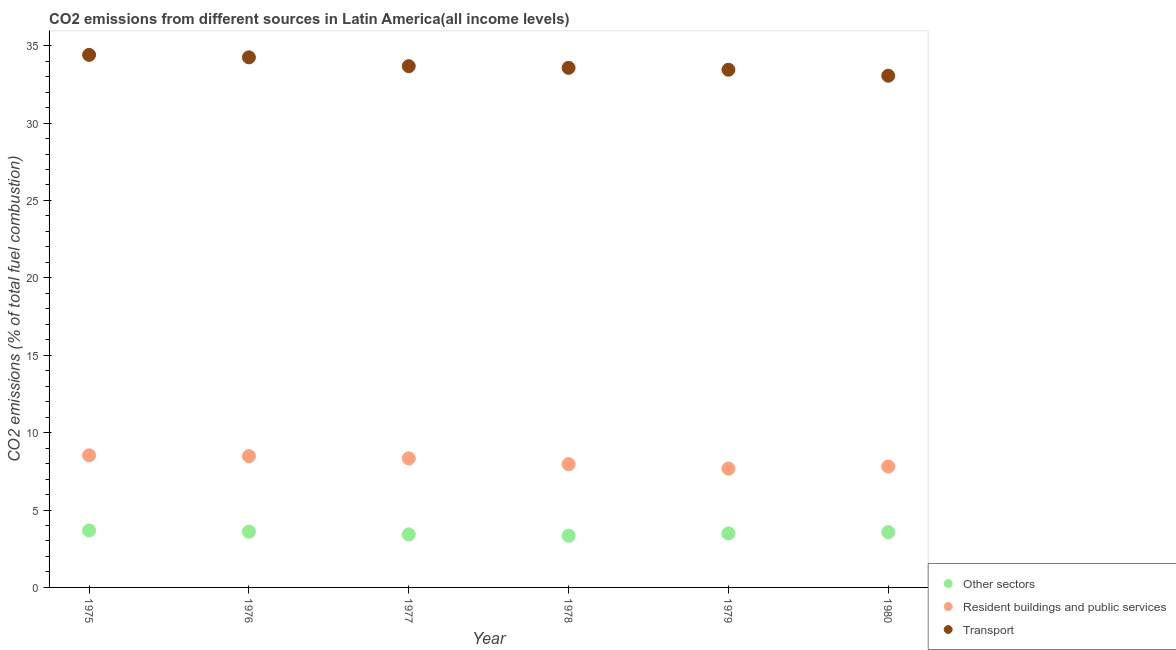Is the number of dotlines equal to the number of legend labels?
Your response must be concise. Yes. What is the percentage of co2 emissions from resident buildings and public services in 1979?
Ensure brevity in your answer.  7.68. Across all years, what is the maximum percentage of co2 emissions from other sectors?
Keep it short and to the point. 3.68. Across all years, what is the minimum percentage of co2 emissions from resident buildings and public services?
Ensure brevity in your answer.  7.68. In which year was the percentage of co2 emissions from transport maximum?
Your response must be concise. 1975. In which year was the percentage of co2 emissions from other sectors minimum?
Offer a very short reply. 1978. What is the total percentage of co2 emissions from resident buildings and public services in the graph?
Provide a succinct answer. 48.82. What is the difference between the percentage of co2 emissions from transport in 1977 and that in 1978?
Your answer should be compact. 0.11. What is the difference between the percentage of co2 emissions from resident buildings and public services in 1978 and the percentage of co2 emissions from transport in 1977?
Provide a succinct answer. -25.72. What is the average percentage of co2 emissions from resident buildings and public services per year?
Keep it short and to the point. 8.14. In the year 1980, what is the difference between the percentage of co2 emissions from resident buildings and public services and percentage of co2 emissions from other sectors?
Offer a terse response. 4.24. What is the ratio of the percentage of co2 emissions from other sectors in 1978 to that in 1979?
Ensure brevity in your answer.  0.96. Is the percentage of co2 emissions from resident buildings and public services in 1976 less than that in 1977?
Your response must be concise. No. What is the difference between the highest and the second highest percentage of co2 emissions from resident buildings and public services?
Give a very brief answer. 0.05. What is the difference between the highest and the lowest percentage of co2 emissions from transport?
Provide a succinct answer. 1.35. In how many years, is the percentage of co2 emissions from transport greater than the average percentage of co2 emissions from transport taken over all years?
Your answer should be very brief. 2. Is it the case that in every year, the sum of the percentage of co2 emissions from other sectors and percentage of co2 emissions from resident buildings and public services is greater than the percentage of co2 emissions from transport?
Provide a succinct answer. No. Is the percentage of co2 emissions from transport strictly greater than the percentage of co2 emissions from other sectors over the years?
Your answer should be compact. Yes. How many dotlines are there?
Your answer should be compact. 3. What is the difference between two consecutive major ticks on the Y-axis?
Your answer should be very brief. 5. Are the values on the major ticks of Y-axis written in scientific E-notation?
Provide a succinct answer. No. Does the graph contain grids?
Your answer should be very brief. No. Where does the legend appear in the graph?
Give a very brief answer. Bottom right. How many legend labels are there?
Make the answer very short. 3. What is the title of the graph?
Keep it short and to the point. CO2 emissions from different sources in Latin America(all income levels). What is the label or title of the Y-axis?
Ensure brevity in your answer.  CO2 emissions (% of total fuel combustion). What is the CO2 emissions (% of total fuel combustion) in Other sectors in 1975?
Make the answer very short. 3.68. What is the CO2 emissions (% of total fuel combustion) in Resident buildings and public services in 1975?
Keep it short and to the point. 8.54. What is the CO2 emissions (% of total fuel combustion) of Transport in 1975?
Ensure brevity in your answer.  34.41. What is the CO2 emissions (% of total fuel combustion) of Other sectors in 1976?
Your answer should be very brief. 3.6. What is the CO2 emissions (% of total fuel combustion) in Resident buildings and public services in 1976?
Provide a short and direct response. 8.48. What is the CO2 emissions (% of total fuel combustion) in Transport in 1976?
Make the answer very short. 34.25. What is the CO2 emissions (% of total fuel combustion) in Other sectors in 1977?
Provide a short and direct response. 3.43. What is the CO2 emissions (% of total fuel combustion) of Resident buildings and public services in 1977?
Offer a terse response. 8.34. What is the CO2 emissions (% of total fuel combustion) in Transport in 1977?
Offer a very short reply. 33.68. What is the CO2 emissions (% of total fuel combustion) of Other sectors in 1978?
Your response must be concise. 3.34. What is the CO2 emissions (% of total fuel combustion) of Resident buildings and public services in 1978?
Offer a very short reply. 7.96. What is the CO2 emissions (% of total fuel combustion) of Transport in 1978?
Offer a terse response. 33.57. What is the CO2 emissions (% of total fuel combustion) of Other sectors in 1979?
Your answer should be compact. 3.49. What is the CO2 emissions (% of total fuel combustion) of Resident buildings and public services in 1979?
Make the answer very short. 7.68. What is the CO2 emissions (% of total fuel combustion) in Transport in 1979?
Offer a terse response. 33.45. What is the CO2 emissions (% of total fuel combustion) in Other sectors in 1980?
Ensure brevity in your answer.  3.57. What is the CO2 emissions (% of total fuel combustion) in Resident buildings and public services in 1980?
Give a very brief answer. 7.82. What is the CO2 emissions (% of total fuel combustion) in Transport in 1980?
Ensure brevity in your answer.  33.06. Across all years, what is the maximum CO2 emissions (% of total fuel combustion) of Other sectors?
Keep it short and to the point. 3.68. Across all years, what is the maximum CO2 emissions (% of total fuel combustion) in Resident buildings and public services?
Ensure brevity in your answer.  8.54. Across all years, what is the maximum CO2 emissions (% of total fuel combustion) of Transport?
Provide a short and direct response. 34.41. Across all years, what is the minimum CO2 emissions (% of total fuel combustion) in Other sectors?
Ensure brevity in your answer.  3.34. Across all years, what is the minimum CO2 emissions (% of total fuel combustion) in Resident buildings and public services?
Give a very brief answer. 7.68. Across all years, what is the minimum CO2 emissions (% of total fuel combustion) of Transport?
Keep it short and to the point. 33.06. What is the total CO2 emissions (% of total fuel combustion) in Other sectors in the graph?
Your answer should be very brief. 21.12. What is the total CO2 emissions (% of total fuel combustion) of Resident buildings and public services in the graph?
Your answer should be compact. 48.82. What is the total CO2 emissions (% of total fuel combustion) of Transport in the graph?
Your answer should be very brief. 202.41. What is the difference between the CO2 emissions (% of total fuel combustion) of Other sectors in 1975 and that in 1976?
Ensure brevity in your answer.  0.08. What is the difference between the CO2 emissions (% of total fuel combustion) of Resident buildings and public services in 1975 and that in 1976?
Make the answer very short. 0.05. What is the difference between the CO2 emissions (% of total fuel combustion) of Transport in 1975 and that in 1976?
Your answer should be compact. 0.16. What is the difference between the CO2 emissions (% of total fuel combustion) of Other sectors in 1975 and that in 1977?
Your answer should be very brief. 0.25. What is the difference between the CO2 emissions (% of total fuel combustion) of Resident buildings and public services in 1975 and that in 1977?
Offer a very short reply. 0.2. What is the difference between the CO2 emissions (% of total fuel combustion) in Transport in 1975 and that in 1977?
Keep it short and to the point. 0.73. What is the difference between the CO2 emissions (% of total fuel combustion) of Other sectors in 1975 and that in 1978?
Offer a terse response. 0.34. What is the difference between the CO2 emissions (% of total fuel combustion) in Resident buildings and public services in 1975 and that in 1978?
Your answer should be compact. 0.58. What is the difference between the CO2 emissions (% of total fuel combustion) of Transport in 1975 and that in 1978?
Offer a terse response. 0.84. What is the difference between the CO2 emissions (% of total fuel combustion) in Other sectors in 1975 and that in 1979?
Your answer should be very brief. 0.19. What is the difference between the CO2 emissions (% of total fuel combustion) of Resident buildings and public services in 1975 and that in 1979?
Your answer should be very brief. 0.86. What is the difference between the CO2 emissions (% of total fuel combustion) in Transport in 1975 and that in 1979?
Give a very brief answer. 0.96. What is the difference between the CO2 emissions (% of total fuel combustion) in Other sectors in 1975 and that in 1980?
Keep it short and to the point. 0.11. What is the difference between the CO2 emissions (% of total fuel combustion) in Resident buildings and public services in 1975 and that in 1980?
Your answer should be very brief. 0.72. What is the difference between the CO2 emissions (% of total fuel combustion) in Transport in 1975 and that in 1980?
Make the answer very short. 1.35. What is the difference between the CO2 emissions (% of total fuel combustion) in Other sectors in 1976 and that in 1977?
Provide a short and direct response. 0.17. What is the difference between the CO2 emissions (% of total fuel combustion) of Resident buildings and public services in 1976 and that in 1977?
Provide a succinct answer. 0.15. What is the difference between the CO2 emissions (% of total fuel combustion) in Transport in 1976 and that in 1977?
Provide a succinct answer. 0.57. What is the difference between the CO2 emissions (% of total fuel combustion) in Other sectors in 1976 and that in 1978?
Make the answer very short. 0.26. What is the difference between the CO2 emissions (% of total fuel combustion) of Resident buildings and public services in 1976 and that in 1978?
Ensure brevity in your answer.  0.52. What is the difference between the CO2 emissions (% of total fuel combustion) in Transport in 1976 and that in 1978?
Offer a very short reply. 0.68. What is the difference between the CO2 emissions (% of total fuel combustion) of Other sectors in 1976 and that in 1979?
Ensure brevity in your answer.  0.11. What is the difference between the CO2 emissions (% of total fuel combustion) in Resident buildings and public services in 1976 and that in 1979?
Offer a terse response. 0.81. What is the difference between the CO2 emissions (% of total fuel combustion) of Other sectors in 1976 and that in 1980?
Make the answer very short. 0.03. What is the difference between the CO2 emissions (% of total fuel combustion) in Resident buildings and public services in 1976 and that in 1980?
Ensure brevity in your answer.  0.67. What is the difference between the CO2 emissions (% of total fuel combustion) of Transport in 1976 and that in 1980?
Your answer should be compact. 1.19. What is the difference between the CO2 emissions (% of total fuel combustion) of Other sectors in 1977 and that in 1978?
Make the answer very short. 0.09. What is the difference between the CO2 emissions (% of total fuel combustion) in Resident buildings and public services in 1977 and that in 1978?
Provide a succinct answer. 0.38. What is the difference between the CO2 emissions (% of total fuel combustion) of Transport in 1977 and that in 1978?
Offer a very short reply. 0.11. What is the difference between the CO2 emissions (% of total fuel combustion) in Other sectors in 1977 and that in 1979?
Your response must be concise. -0.06. What is the difference between the CO2 emissions (% of total fuel combustion) in Resident buildings and public services in 1977 and that in 1979?
Offer a very short reply. 0.66. What is the difference between the CO2 emissions (% of total fuel combustion) in Transport in 1977 and that in 1979?
Make the answer very short. 0.23. What is the difference between the CO2 emissions (% of total fuel combustion) of Other sectors in 1977 and that in 1980?
Make the answer very short. -0.14. What is the difference between the CO2 emissions (% of total fuel combustion) of Resident buildings and public services in 1977 and that in 1980?
Provide a short and direct response. 0.52. What is the difference between the CO2 emissions (% of total fuel combustion) in Transport in 1977 and that in 1980?
Ensure brevity in your answer.  0.62. What is the difference between the CO2 emissions (% of total fuel combustion) of Other sectors in 1978 and that in 1979?
Offer a very short reply. -0.15. What is the difference between the CO2 emissions (% of total fuel combustion) in Resident buildings and public services in 1978 and that in 1979?
Make the answer very short. 0.28. What is the difference between the CO2 emissions (% of total fuel combustion) of Transport in 1978 and that in 1979?
Provide a succinct answer. 0.12. What is the difference between the CO2 emissions (% of total fuel combustion) of Other sectors in 1978 and that in 1980?
Ensure brevity in your answer.  -0.23. What is the difference between the CO2 emissions (% of total fuel combustion) in Resident buildings and public services in 1978 and that in 1980?
Your answer should be very brief. 0.15. What is the difference between the CO2 emissions (% of total fuel combustion) in Transport in 1978 and that in 1980?
Your answer should be compact. 0.51. What is the difference between the CO2 emissions (% of total fuel combustion) of Other sectors in 1979 and that in 1980?
Provide a succinct answer. -0.08. What is the difference between the CO2 emissions (% of total fuel combustion) of Resident buildings and public services in 1979 and that in 1980?
Your response must be concise. -0.14. What is the difference between the CO2 emissions (% of total fuel combustion) in Transport in 1979 and that in 1980?
Ensure brevity in your answer.  0.39. What is the difference between the CO2 emissions (% of total fuel combustion) of Other sectors in 1975 and the CO2 emissions (% of total fuel combustion) of Resident buildings and public services in 1976?
Offer a terse response. -4.8. What is the difference between the CO2 emissions (% of total fuel combustion) in Other sectors in 1975 and the CO2 emissions (% of total fuel combustion) in Transport in 1976?
Your response must be concise. -30.57. What is the difference between the CO2 emissions (% of total fuel combustion) in Resident buildings and public services in 1975 and the CO2 emissions (% of total fuel combustion) in Transport in 1976?
Provide a short and direct response. -25.71. What is the difference between the CO2 emissions (% of total fuel combustion) in Other sectors in 1975 and the CO2 emissions (% of total fuel combustion) in Resident buildings and public services in 1977?
Provide a succinct answer. -4.66. What is the difference between the CO2 emissions (% of total fuel combustion) in Other sectors in 1975 and the CO2 emissions (% of total fuel combustion) in Transport in 1977?
Ensure brevity in your answer.  -30. What is the difference between the CO2 emissions (% of total fuel combustion) in Resident buildings and public services in 1975 and the CO2 emissions (% of total fuel combustion) in Transport in 1977?
Your answer should be very brief. -25.14. What is the difference between the CO2 emissions (% of total fuel combustion) in Other sectors in 1975 and the CO2 emissions (% of total fuel combustion) in Resident buildings and public services in 1978?
Provide a short and direct response. -4.28. What is the difference between the CO2 emissions (% of total fuel combustion) of Other sectors in 1975 and the CO2 emissions (% of total fuel combustion) of Transport in 1978?
Offer a very short reply. -29.89. What is the difference between the CO2 emissions (% of total fuel combustion) in Resident buildings and public services in 1975 and the CO2 emissions (% of total fuel combustion) in Transport in 1978?
Provide a short and direct response. -25.03. What is the difference between the CO2 emissions (% of total fuel combustion) in Other sectors in 1975 and the CO2 emissions (% of total fuel combustion) in Resident buildings and public services in 1979?
Offer a terse response. -4. What is the difference between the CO2 emissions (% of total fuel combustion) in Other sectors in 1975 and the CO2 emissions (% of total fuel combustion) in Transport in 1979?
Keep it short and to the point. -29.77. What is the difference between the CO2 emissions (% of total fuel combustion) in Resident buildings and public services in 1975 and the CO2 emissions (% of total fuel combustion) in Transport in 1979?
Provide a succinct answer. -24.91. What is the difference between the CO2 emissions (% of total fuel combustion) in Other sectors in 1975 and the CO2 emissions (% of total fuel combustion) in Resident buildings and public services in 1980?
Your response must be concise. -4.14. What is the difference between the CO2 emissions (% of total fuel combustion) of Other sectors in 1975 and the CO2 emissions (% of total fuel combustion) of Transport in 1980?
Provide a succinct answer. -29.38. What is the difference between the CO2 emissions (% of total fuel combustion) in Resident buildings and public services in 1975 and the CO2 emissions (% of total fuel combustion) in Transport in 1980?
Give a very brief answer. -24.52. What is the difference between the CO2 emissions (% of total fuel combustion) in Other sectors in 1976 and the CO2 emissions (% of total fuel combustion) in Resident buildings and public services in 1977?
Your answer should be compact. -4.73. What is the difference between the CO2 emissions (% of total fuel combustion) of Other sectors in 1976 and the CO2 emissions (% of total fuel combustion) of Transport in 1977?
Keep it short and to the point. -30.07. What is the difference between the CO2 emissions (% of total fuel combustion) in Resident buildings and public services in 1976 and the CO2 emissions (% of total fuel combustion) in Transport in 1977?
Provide a short and direct response. -25.19. What is the difference between the CO2 emissions (% of total fuel combustion) in Other sectors in 1976 and the CO2 emissions (% of total fuel combustion) in Resident buildings and public services in 1978?
Keep it short and to the point. -4.36. What is the difference between the CO2 emissions (% of total fuel combustion) of Other sectors in 1976 and the CO2 emissions (% of total fuel combustion) of Transport in 1978?
Your answer should be compact. -29.97. What is the difference between the CO2 emissions (% of total fuel combustion) in Resident buildings and public services in 1976 and the CO2 emissions (% of total fuel combustion) in Transport in 1978?
Give a very brief answer. -25.09. What is the difference between the CO2 emissions (% of total fuel combustion) in Other sectors in 1976 and the CO2 emissions (% of total fuel combustion) in Resident buildings and public services in 1979?
Provide a succinct answer. -4.08. What is the difference between the CO2 emissions (% of total fuel combustion) in Other sectors in 1976 and the CO2 emissions (% of total fuel combustion) in Transport in 1979?
Provide a succinct answer. -29.84. What is the difference between the CO2 emissions (% of total fuel combustion) in Resident buildings and public services in 1976 and the CO2 emissions (% of total fuel combustion) in Transport in 1979?
Your answer should be compact. -24.96. What is the difference between the CO2 emissions (% of total fuel combustion) in Other sectors in 1976 and the CO2 emissions (% of total fuel combustion) in Resident buildings and public services in 1980?
Your answer should be very brief. -4.21. What is the difference between the CO2 emissions (% of total fuel combustion) of Other sectors in 1976 and the CO2 emissions (% of total fuel combustion) of Transport in 1980?
Your answer should be compact. -29.46. What is the difference between the CO2 emissions (% of total fuel combustion) in Resident buildings and public services in 1976 and the CO2 emissions (% of total fuel combustion) in Transport in 1980?
Offer a terse response. -24.58. What is the difference between the CO2 emissions (% of total fuel combustion) of Other sectors in 1977 and the CO2 emissions (% of total fuel combustion) of Resident buildings and public services in 1978?
Your response must be concise. -4.53. What is the difference between the CO2 emissions (% of total fuel combustion) in Other sectors in 1977 and the CO2 emissions (% of total fuel combustion) in Transport in 1978?
Provide a succinct answer. -30.14. What is the difference between the CO2 emissions (% of total fuel combustion) of Resident buildings and public services in 1977 and the CO2 emissions (% of total fuel combustion) of Transport in 1978?
Provide a short and direct response. -25.23. What is the difference between the CO2 emissions (% of total fuel combustion) of Other sectors in 1977 and the CO2 emissions (% of total fuel combustion) of Resident buildings and public services in 1979?
Provide a short and direct response. -4.25. What is the difference between the CO2 emissions (% of total fuel combustion) of Other sectors in 1977 and the CO2 emissions (% of total fuel combustion) of Transport in 1979?
Ensure brevity in your answer.  -30.02. What is the difference between the CO2 emissions (% of total fuel combustion) of Resident buildings and public services in 1977 and the CO2 emissions (% of total fuel combustion) of Transport in 1979?
Your answer should be compact. -25.11. What is the difference between the CO2 emissions (% of total fuel combustion) of Other sectors in 1977 and the CO2 emissions (% of total fuel combustion) of Resident buildings and public services in 1980?
Provide a short and direct response. -4.39. What is the difference between the CO2 emissions (% of total fuel combustion) in Other sectors in 1977 and the CO2 emissions (% of total fuel combustion) in Transport in 1980?
Provide a short and direct response. -29.63. What is the difference between the CO2 emissions (% of total fuel combustion) in Resident buildings and public services in 1977 and the CO2 emissions (% of total fuel combustion) in Transport in 1980?
Keep it short and to the point. -24.72. What is the difference between the CO2 emissions (% of total fuel combustion) in Other sectors in 1978 and the CO2 emissions (% of total fuel combustion) in Resident buildings and public services in 1979?
Offer a very short reply. -4.34. What is the difference between the CO2 emissions (% of total fuel combustion) in Other sectors in 1978 and the CO2 emissions (% of total fuel combustion) in Transport in 1979?
Provide a short and direct response. -30.1. What is the difference between the CO2 emissions (% of total fuel combustion) of Resident buildings and public services in 1978 and the CO2 emissions (% of total fuel combustion) of Transport in 1979?
Ensure brevity in your answer.  -25.49. What is the difference between the CO2 emissions (% of total fuel combustion) in Other sectors in 1978 and the CO2 emissions (% of total fuel combustion) in Resident buildings and public services in 1980?
Ensure brevity in your answer.  -4.47. What is the difference between the CO2 emissions (% of total fuel combustion) in Other sectors in 1978 and the CO2 emissions (% of total fuel combustion) in Transport in 1980?
Give a very brief answer. -29.72. What is the difference between the CO2 emissions (% of total fuel combustion) of Resident buildings and public services in 1978 and the CO2 emissions (% of total fuel combustion) of Transport in 1980?
Your answer should be very brief. -25.1. What is the difference between the CO2 emissions (% of total fuel combustion) of Other sectors in 1979 and the CO2 emissions (% of total fuel combustion) of Resident buildings and public services in 1980?
Your answer should be compact. -4.32. What is the difference between the CO2 emissions (% of total fuel combustion) in Other sectors in 1979 and the CO2 emissions (% of total fuel combustion) in Transport in 1980?
Your answer should be very brief. -29.57. What is the difference between the CO2 emissions (% of total fuel combustion) in Resident buildings and public services in 1979 and the CO2 emissions (% of total fuel combustion) in Transport in 1980?
Make the answer very short. -25.38. What is the average CO2 emissions (% of total fuel combustion) in Other sectors per year?
Offer a terse response. 3.52. What is the average CO2 emissions (% of total fuel combustion) of Resident buildings and public services per year?
Your response must be concise. 8.14. What is the average CO2 emissions (% of total fuel combustion) of Transport per year?
Ensure brevity in your answer.  33.73. In the year 1975, what is the difference between the CO2 emissions (% of total fuel combustion) of Other sectors and CO2 emissions (% of total fuel combustion) of Resident buildings and public services?
Give a very brief answer. -4.86. In the year 1975, what is the difference between the CO2 emissions (% of total fuel combustion) in Other sectors and CO2 emissions (% of total fuel combustion) in Transport?
Provide a succinct answer. -30.73. In the year 1975, what is the difference between the CO2 emissions (% of total fuel combustion) of Resident buildings and public services and CO2 emissions (% of total fuel combustion) of Transport?
Provide a short and direct response. -25.87. In the year 1976, what is the difference between the CO2 emissions (% of total fuel combustion) in Other sectors and CO2 emissions (% of total fuel combustion) in Resident buildings and public services?
Offer a very short reply. -4.88. In the year 1976, what is the difference between the CO2 emissions (% of total fuel combustion) of Other sectors and CO2 emissions (% of total fuel combustion) of Transport?
Give a very brief answer. -30.64. In the year 1976, what is the difference between the CO2 emissions (% of total fuel combustion) of Resident buildings and public services and CO2 emissions (% of total fuel combustion) of Transport?
Provide a succinct answer. -25.76. In the year 1977, what is the difference between the CO2 emissions (% of total fuel combustion) of Other sectors and CO2 emissions (% of total fuel combustion) of Resident buildings and public services?
Keep it short and to the point. -4.91. In the year 1977, what is the difference between the CO2 emissions (% of total fuel combustion) of Other sectors and CO2 emissions (% of total fuel combustion) of Transport?
Your response must be concise. -30.25. In the year 1977, what is the difference between the CO2 emissions (% of total fuel combustion) of Resident buildings and public services and CO2 emissions (% of total fuel combustion) of Transport?
Provide a succinct answer. -25.34. In the year 1978, what is the difference between the CO2 emissions (% of total fuel combustion) of Other sectors and CO2 emissions (% of total fuel combustion) of Resident buildings and public services?
Ensure brevity in your answer.  -4.62. In the year 1978, what is the difference between the CO2 emissions (% of total fuel combustion) of Other sectors and CO2 emissions (% of total fuel combustion) of Transport?
Keep it short and to the point. -30.23. In the year 1978, what is the difference between the CO2 emissions (% of total fuel combustion) in Resident buildings and public services and CO2 emissions (% of total fuel combustion) in Transport?
Give a very brief answer. -25.61. In the year 1979, what is the difference between the CO2 emissions (% of total fuel combustion) of Other sectors and CO2 emissions (% of total fuel combustion) of Resident buildings and public services?
Your answer should be compact. -4.19. In the year 1979, what is the difference between the CO2 emissions (% of total fuel combustion) of Other sectors and CO2 emissions (% of total fuel combustion) of Transport?
Keep it short and to the point. -29.95. In the year 1979, what is the difference between the CO2 emissions (% of total fuel combustion) in Resident buildings and public services and CO2 emissions (% of total fuel combustion) in Transport?
Provide a succinct answer. -25.77. In the year 1980, what is the difference between the CO2 emissions (% of total fuel combustion) of Other sectors and CO2 emissions (% of total fuel combustion) of Resident buildings and public services?
Your answer should be very brief. -4.24. In the year 1980, what is the difference between the CO2 emissions (% of total fuel combustion) of Other sectors and CO2 emissions (% of total fuel combustion) of Transport?
Offer a very short reply. -29.49. In the year 1980, what is the difference between the CO2 emissions (% of total fuel combustion) in Resident buildings and public services and CO2 emissions (% of total fuel combustion) in Transport?
Offer a terse response. -25.24. What is the ratio of the CO2 emissions (% of total fuel combustion) in Other sectors in 1975 to that in 1976?
Your response must be concise. 1.02. What is the ratio of the CO2 emissions (% of total fuel combustion) in Resident buildings and public services in 1975 to that in 1976?
Your answer should be compact. 1.01. What is the ratio of the CO2 emissions (% of total fuel combustion) of Transport in 1975 to that in 1976?
Give a very brief answer. 1. What is the ratio of the CO2 emissions (% of total fuel combustion) of Other sectors in 1975 to that in 1977?
Provide a short and direct response. 1.07. What is the ratio of the CO2 emissions (% of total fuel combustion) in Resident buildings and public services in 1975 to that in 1977?
Provide a short and direct response. 1.02. What is the ratio of the CO2 emissions (% of total fuel combustion) in Transport in 1975 to that in 1977?
Keep it short and to the point. 1.02. What is the ratio of the CO2 emissions (% of total fuel combustion) of Other sectors in 1975 to that in 1978?
Provide a succinct answer. 1.1. What is the ratio of the CO2 emissions (% of total fuel combustion) of Resident buildings and public services in 1975 to that in 1978?
Ensure brevity in your answer.  1.07. What is the ratio of the CO2 emissions (% of total fuel combustion) in Transport in 1975 to that in 1978?
Offer a very short reply. 1.02. What is the ratio of the CO2 emissions (% of total fuel combustion) of Other sectors in 1975 to that in 1979?
Ensure brevity in your answer.  1.05. What is the ratio of the CO2 emissions (% of total fuel combustion) in Resident buildings and public services in 1975 to that in 1979?
Ensure brevity in your answer.  1.11. What is the ratio of the CO2 emissions (% of total fuel combustion) of Transport in 1975 to that in 1979?
Ensure brevity in your answer.  1.03. What is the ratio of the CO2 emissions (% of total fuel combustion) of Other sectors in 1975 to that in 1980?
Make the answer very short. 1.03. What is the ratio of the CO2 emissions (% of total fuel combustion) in Resident buildings and public services in 1975 to that in 1980?
Offer a terse response. 1.09. What is the ratio of the CO2 emissions (% of total fuel combustion) of Transport in 1975 to that in 1980?
Offer a terse response. 1.04. What is the ratio of the CO2 emissions (% of total fuel combustion) in Other sectors in 1976 to that in 1977?
Offer a terse response. 1.05. What is the ratio of the CO2 emissions (% of total fuel combustion) in Resident buildings and public services in 1976 to that in 1977?
Your answer should be compact. 1.02. What is the ratio of the CO2 emissions (% of total fuel combustion) of Transport in 1976 to that in 1977?
Your answer should be compact. 1.02. What is the ratio of the CO2 emissions (% of total fuel combustion) in Other sectors in 1976 to that in 1978?
Your answer should be compact. 1.08. What is the ratio of the CO2 emissions (% of total fuel combustion) of Resident buildings and public services in 1976 to that in 1978?
Provide a succinct answer. 1.07. What is the ratio of the CO2 emissions (% of total fuel combustion) of Transport in 1976 to that in 1978?
Give a very brief answer. 1.02. What is the ratio of the CO2 emissions (% of total fuel combustion) of Other sectors in 1976 to that in 1979?
Make the answer very short. 1.03. What is the ratio of the CO2 emissions (% of total fuel combustion) of Resident buildings and public services in 1976 to that in 1979?
Keep it short and to the point. 1.1. What is the ratio of the CO2 emissions (% of total fuel combustion) of Transport in 1976 to that in 1979?
Make the answer very short. 1.02. What is the ratio of the CO2 emissions (% of total fuel combustion) in Other sectors in 1976 to that in 1980?
Provide a short and direct response. 1.01. What is the ratio of the CO2 emissions (% of total fuel combustion) of Resident buildings and public services in 1976 to that in 1980?
Your answer should be very brief. 1.09. What is the ratio of the CO2 emissions (% of total fuel combustion) of Transport in 1976 to that in 1980?
Offer a very short reply. 1.04. What is the ratio of the CO2 emissions (% of total fuel combustion) of Resident buildings and public services in 1977 to that in 1978?
Give a very brief answer. 1.05. What is the ratio of the CO2 emissions (% of total fuel combustion) in Other sectors in 1977 to that in 1979?
Make the answer very short. 0.98. What is the ratio of the CO2 emissions (% of total fuel combustion) of Resident buildings and public services in 1977 to that in 1979?
Provide a succinct answer. 1.09. What is the ratio of the CO2 emissions (% of total fuel combustion) of Resident buildings and public services in 1977 to that in 1980?
Ensure brevity in your answer.  1.07. What is the ratio of the CO2 emissions (% of total fuel combustion) of Transport in 1977 to that in 1980?
Keep it short and to the point. 1.02. What is the ratio of the CO2 emissions (% of total fuel combustion) in Other sectors in 1978 to that in 1979?
Make the answer very short. 0.96. What is the ratio of the CO2 emissions (% of total fuel combustion) of Resident buildings and public services in 1978 to that in 1979?
Make the answer very short. 1.04. What is the ratio of the CO2 emissions (% of total fuel combustion) in Other sectors in 1978 to that in 1980?
Make the answer very short. 0.94. What is the ratio of the CO2 emissions (% of total fuel combustion) of Resident buildings and public services in 1978 to that in 1980?
Offer a very short reply. 1.02. What is the ratio of the CO2 emissions (% of total fuel combustion) of Transport in 1978 to that in 1980?
Provide a short and direct response. 1.02. What is the ratio of the CO2 emissions (% of total fuel combustion) in Other sectors in 1979 to that in 1980?
Your response must be concise. 0.98. What is the ratio of the CO2 emissions (% of total fuel combustion) of Resident buildings and public services in 1979 to that in 1980?
Give a very brief answer. 0.98. What is the ratio of the CO2 emissions (% of total fuel combustion) of Transport in 1979 to that in 1980?
Your answer should be very brief. 1.01. What is the difference between the highest and the second highest CO2 emissions (% of total fuel combustion) in Other sectors?
Ensure brevity in your answer.  0.08. What is the difference between the highest and the second highest CO2 emissions (% of total fuel combustion) in Resident buildings and public services?
Your answer should be very brief. 0.05. What is the difference between the highest and the second highest CO2 emissions (% of total fuel combustion) of Transport?
Your response must be concise. 0.16. What is the difference between the highest and the lowest CO2 emissions (% of total fuel combustion) in Other sectors?
Ensure brevity in your answer.  0.34. What is the difference between the highest and the lowest CO2 emissions (% of total fuel combustion) in Resident buildings and public services?
Make the answer very short. 0.86. What is the difference between the highest and the lowest CO2 emissions (% of total fuel combustion) of Transport?
Offer a terse response. 1.35. 